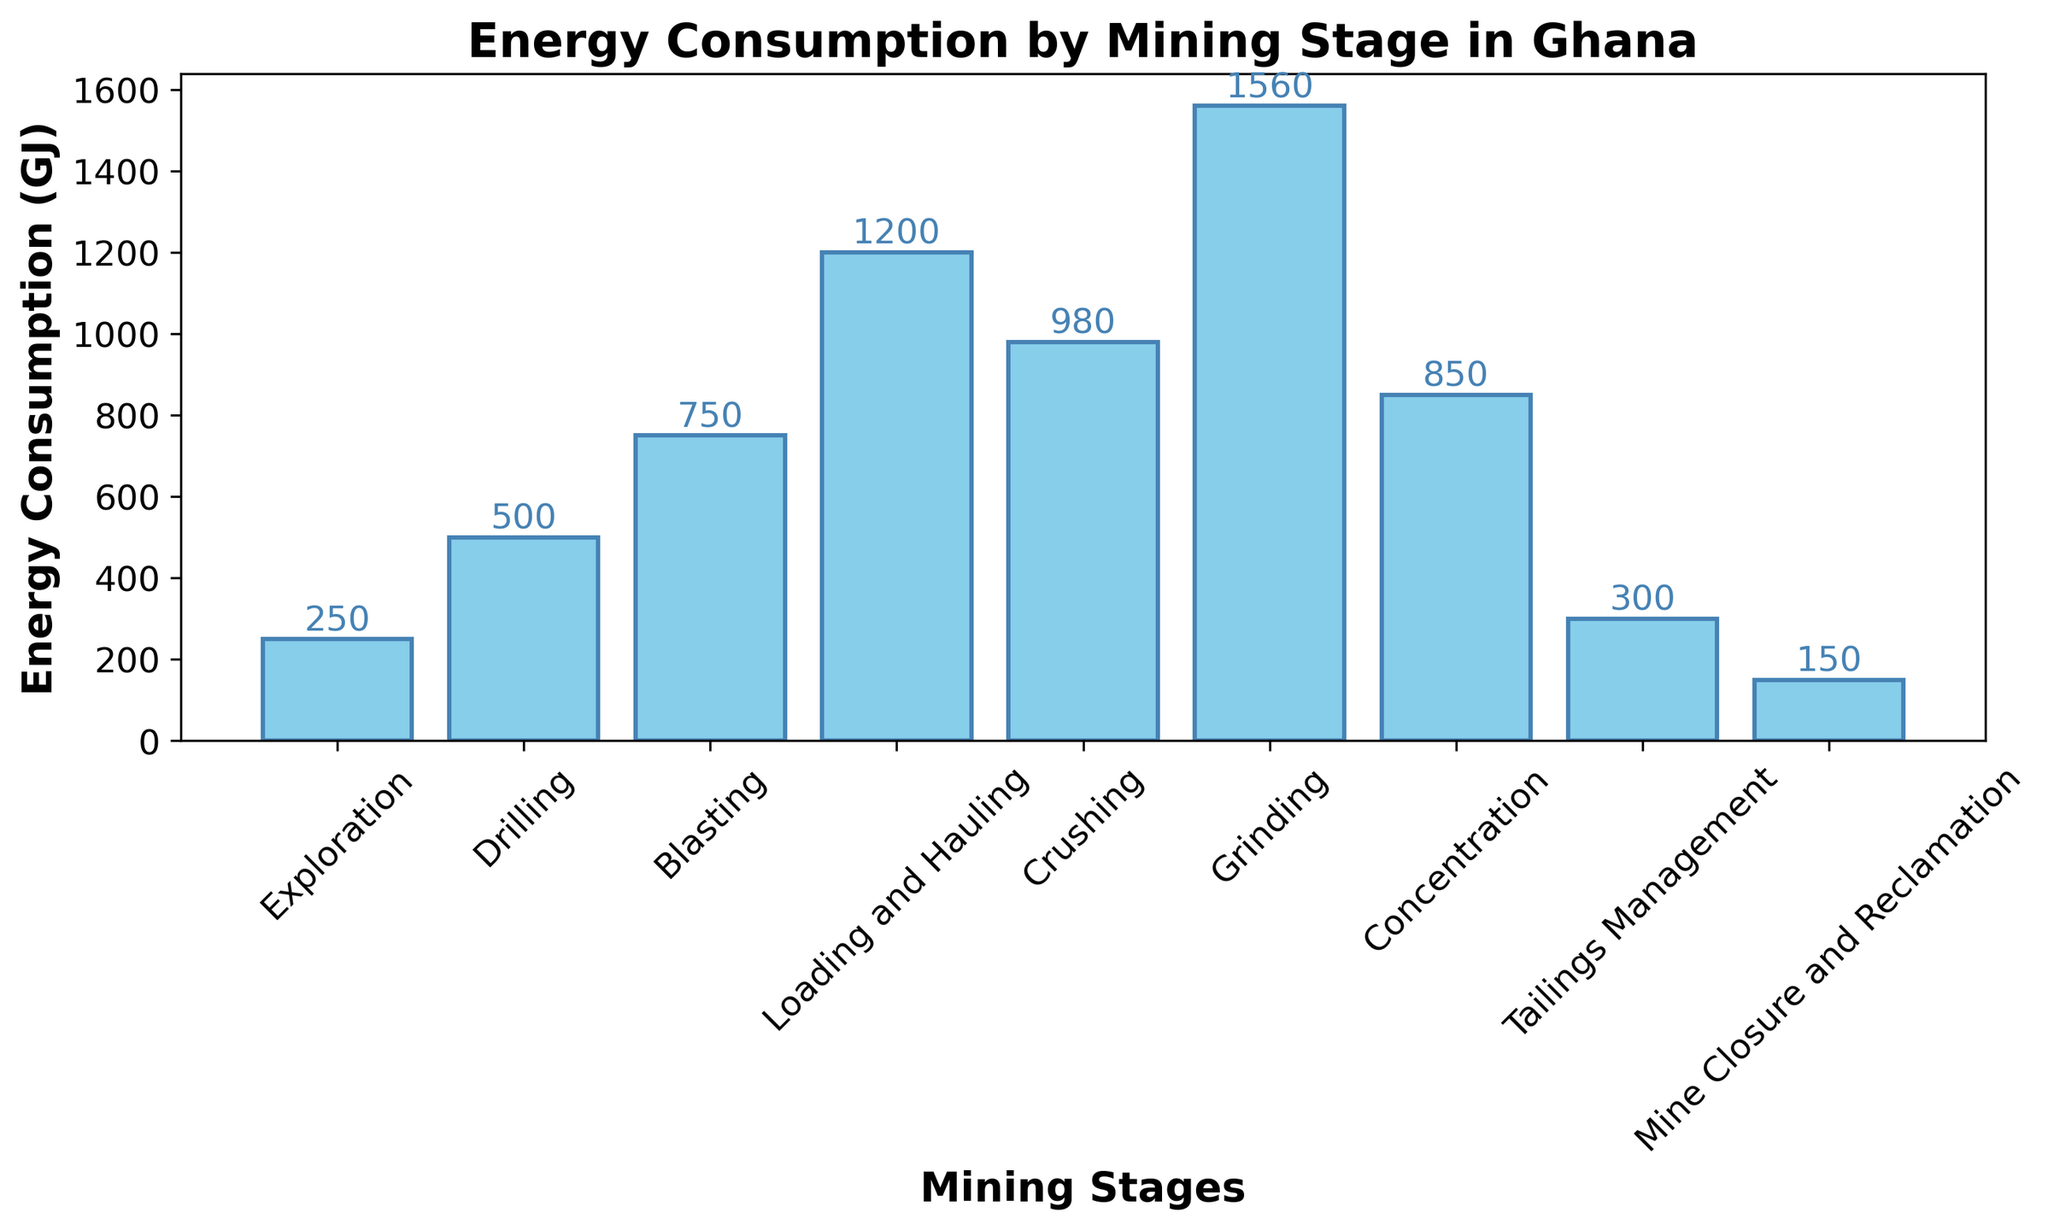What stage has the highest energy consumption? The bar representing the Grinding stage is visually the highest, indicating it has the greatest energy consumption.
Answer: Grinding Which stage consumes less energy: Blasting or Concentration? Compare the heights of the bars for Blasting and Concentration. The Blasting stage bar is taller than the Concentration stage bar, signifying that Blasting consumes more energy.
Answer: Concentration How much more energy does Loading and Hauling consume compared to Exploration? Subtract the energy consumption for Exploration (250 GJ) from Loading and Hauling (1200 GJ). The difference is 1200 GJ - 250 GJ = 950 GJ.
Answer: 950 GJ What is the total energy consumption for Drilling and Blasting combined? Add the energy consumptions for Drilling (500 GJ) and Blasting (750 GJ). The total is 500 GJ + 750 GJ = 1250 GJ.
Answer: 1250 GJ Which stage has the smallest energy consumption and how much is it? The shortest bar corresponds to the Mine Closure and Reclamation stage, indicating the smallest energy consumption of 150 GJ.
Answer: Mine Closure and Reclamation What stages have energy consumption higher than 800 GJ? Identify the stages where the bars exceed the 800 GJ mark. The stages are Loading and Hauling (1200 GJ), Crushing (980 GJ), Grinding (1560 GJ), and Concentration (850 GJ).
Answer: Loading and Hauling, Crushing, Grinding, Concentration Is the energy consumption for Crushing greater than the combined energy consumption of Exploration and Tailings Management? Add the energy consumption for Exploration (250 GJ) and Tailings Management (300 GJ). The sum is 250 GJ + 300 GJ = 550 GJ. Since Crushing (980 GJ) is greater than 550 GJ, the statement is true.
Answer: Yes What is the average energy consumption across all stages? Sum the energy consumptions for all stages (250 + 500 + 750 + 1200 + 980 + 1560 + 850 + 300 + 150 = 6540 GJ), then divide by the number of stages (9). The average is 6540 GJ / 9 ≈ 726.67 GJ.
Answer: 726.67 GJ What is the difference between the highest and lowest energy consumption stages? Subtract the energy consumption of the lowest stage, Mine Closure and Reclamation (150 GJ), from the highest stage, Grinding (1560 GJ). The difference is 1560 GJ - 150 GJ = 1410 GJ.
Answer: 1410 GJ 